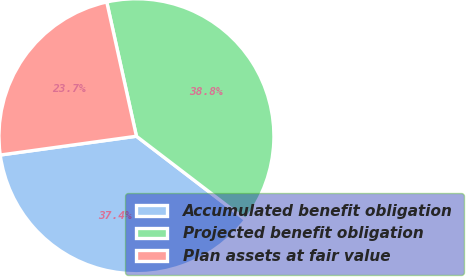Convert chart to OTSL. <chart><loc_0><loc_0><loc_500><loc_500><pie_chart><fcel>Accumulated benefit obligation<fcel>Projected benefit obligation<fcel>Plan assets at fair value<nl><fcel>37.43%<fcel>38.85%<fcel>23.72%<nl></chart> 